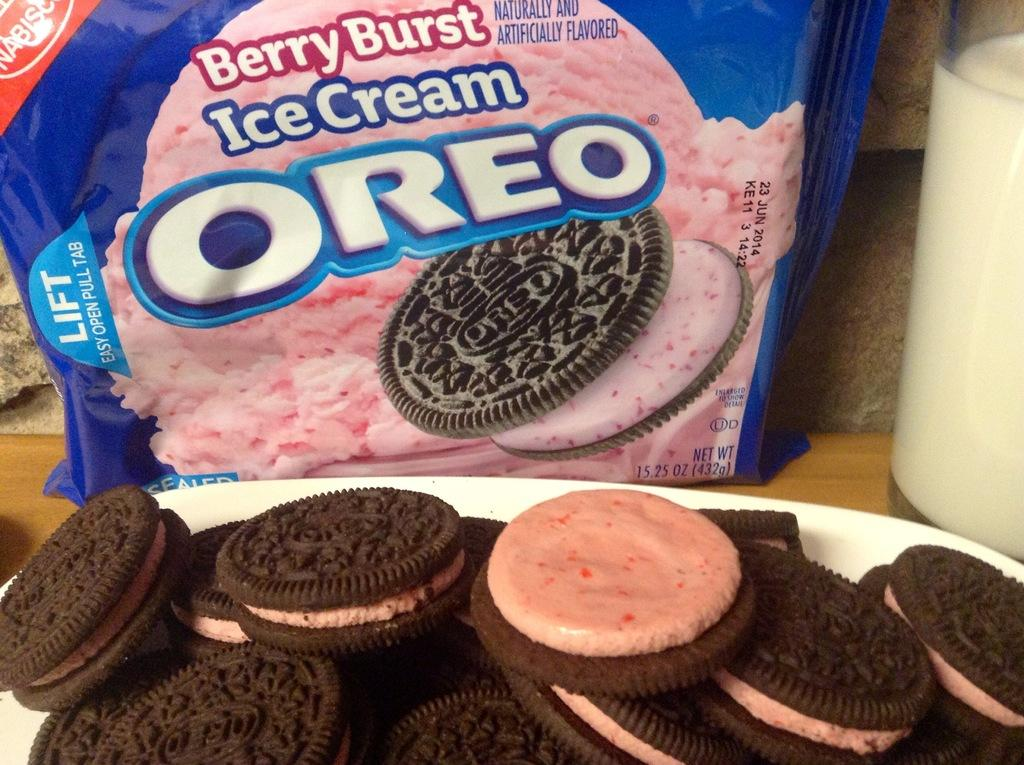What piece of furniture is present in the image? There is a table in the image. What is placed on the table? There is a glass and a plate on the table. What is on the plate? There are biscuits in the plate. What type of flower is growing on the table in the image? There are no flowers present on the table in the image. 